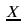Convert formula to latex. <formula><loc_0><loc_0><loc_500><loc_500>\underline { X }</formula> 